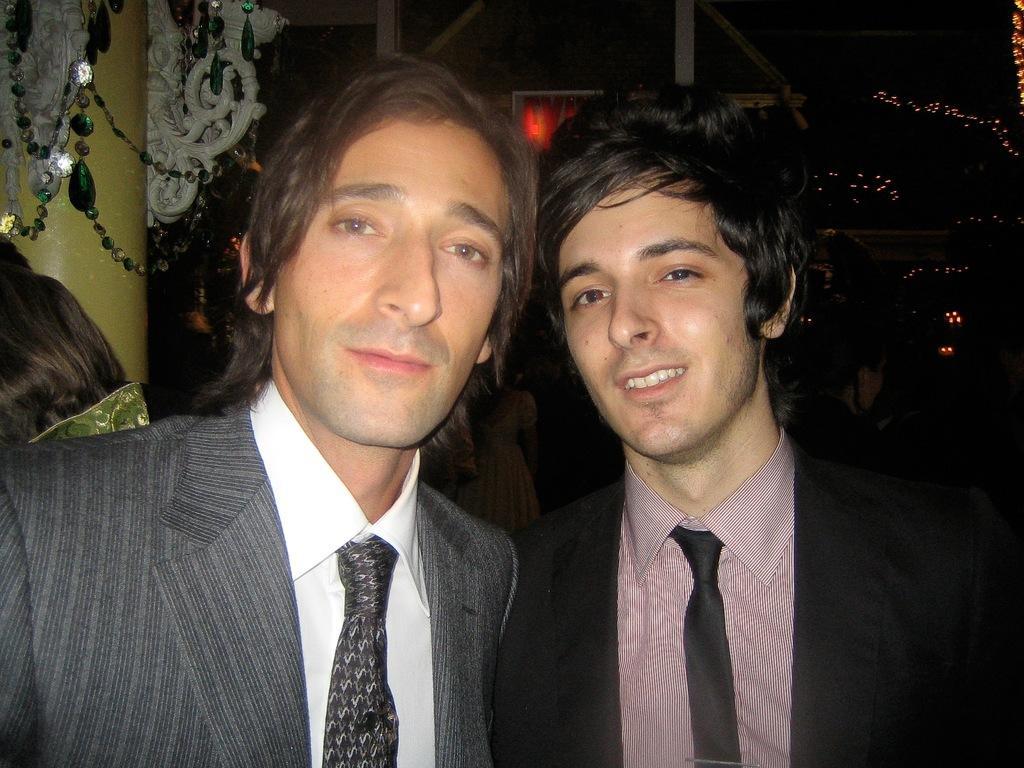Please provide a concise description of this image. In the center of the image we can see two persons are standing and wearing suit, ties. In the background of the image we can see the wall, decor and lights. 